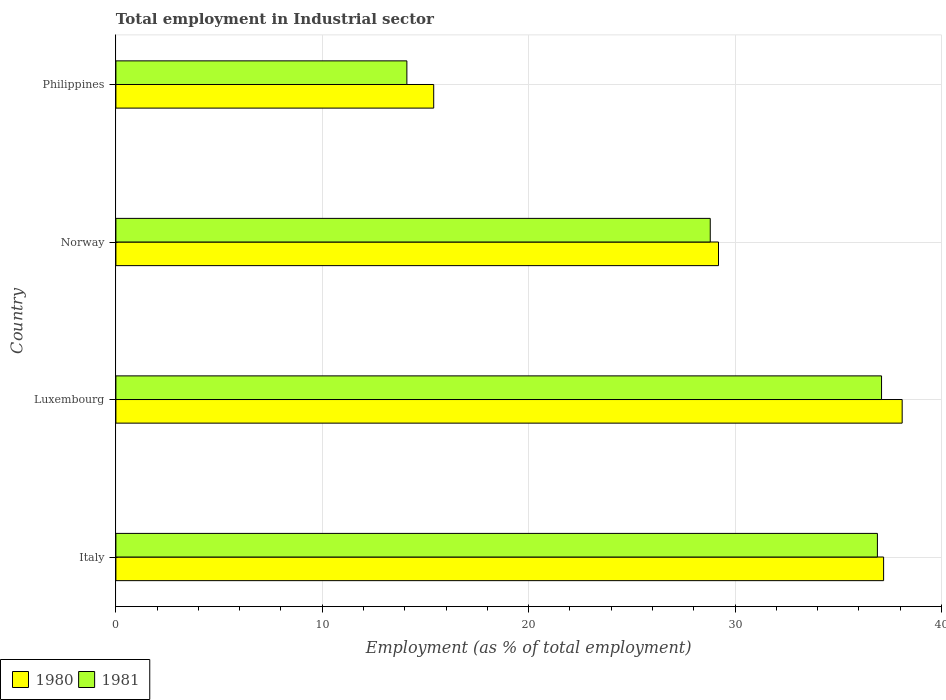How many different coloured bars are there?
Keep it short and to the point. 2. How many groups of bars are there?
Your response must be concise. 4. Are the number of bars on each tick of the Y-axis equal?
Provide a succinct answer. Yes. How many bars are there on the 1st tick from the top?
Provide a succinct answer. 2. What is the label of the 3rd group of bars from the top?
Ensure brevity in your answer.  Luxembourg. What is the employment in industrial sector in 1980 in Italy?
Keep it short and to the point. 37.2. Across all countries, what is the maximum employment in industrial sector in 1981?
Offer a terse response. 37.1. Across all countries, what is the minimum employment in industrial sector in 1981?
Keep it short and to the point. 14.1. In which country was the employment in industrial sector in 1981 maximum?
Offer a terse response. Luxembourg. What is the total employment in industrial sector in 1981 in the graph?
Your answer should be very brief. 116.9. What is the difference between the employment in industrial sector in 1980 in Luxembourg and that in Philippines?
Make the answer very short. 22.7. What is the difference between the employment in industrial sector in 1980 in Italy and the employment in industrial sector in 1981 in Norway?
Your answer should be compact. 8.4. What is the average employment in industrial sector in 1980 per country?
Give a very brief answer. 29.97. What is the difference between the employment in industrial sector in 1981 and employment in industrial sector in 1980 in Luxembourg?
Your response must be concise. -1. What is the ratio of the employment in industrial sector in 1980 in Italy to that in Philippines?
Offer a terse response. 2.42. Is the employment in industrial sector in 1980 in Luxembourg less than that in Philippines?
Offer a very short reply. No. What is the difference between the highest and the second highest employment in industrial sector in 1980?
Ensure brevity in your answer.  0.9. What is the difference between the highest and the lowest employment in industrial sector in 1980?
Ensure brevity in your answer.  22.7. What is the difference between two consecutive major ticks on the X-axis?
Provide a succinct answer. 10. Does the graph contain any zero values?
Offer a very short reply. No. Where does the legend appear in the graph?
Offer a very short reply. Bottom left. How many legend labels are there?
Provide a short and direct response. 2. What is the title of the graph?
Offer a terse response. Total employment in Industrial sector. What is the label or title of the X-axis?
Give a very brief answer. Employment (as % of total employment). What is the label or title of the Y-axis?
Ensure brevity in your answer.  Country. What is the Employment (as % of total employment) in 1980 in Italy?
Your answer should be very brief. 37.2. What is the Employment (as % of total employment) in 1981 in Italy?
Offer a terse response. 36.9. What is the Employment (as % of total employment) of 1980 in Luxembourg?
Offer a very short reply. 38.1. What is the Employment (as % of total employment) of 1981 in Luxembourg?
Give a very brief answer. 37.1. What is the Employment (as % of total employment) of 1980 in Norway?
Provide a succinct answer. 29.2. What is the Employment (as % of total employment) of 1981 in Norway?
Your response must be concise. 28.8. What is the Employment (as % of total employment) in 1980 in Philippines?
Ensure brevity in your answer.  15.4. What is the Employment (as % of total employment) of 1981 in Philippines?
Provide a succinct answer. 14.1. Across all countries, what is the maximum Employment (as % of total employment) of 1980?
Offer a very short reply. 38.1. Across all countries, what is the maximum Employment (as % of total employment) in 1981?
Your answer should be compact. 37.1. Across all countries, what is the minimum Employment (as % of total employment) in 1980?
Your answer should be very brief. 15.4. Across all countries, what is the minimum Employment (as % of total employment) in 1981?
Give a very brief answer. 14.1. What is the total Employment (as % of total employment) of 1980 in the graph?
Give a very brief answer. 119.9. What is the total Employment (as % of total employment) in 1981 in the graph?
Make the answer very short. 116.9. What is the difference between the Employment (as % of total employment) in 1980 in Italy and that in Philippines?
Ensure brevity in your answer.  21.8. What is the difference between the Employment (as % of total employment) of 1981 in Italy and that in Philippines?
Your answer should be compact. 22.8. What is the difference between the Employment (as % of total employment) in 1980 in Luxembourg and that in Norway?
Keep it short and to the point. 8.9. What is the difference between the Employment (as % of total employment) in 1980 in Luxembourg and that in Philippines?
Your answer should be compact. 22.7. What is the difference between the Employment (as % of total employment) in 1981 in Norway and that in Philippines?
Ensure brevity in your answer.  14.7. What is the difference between the Employment (as % of total employment) of 1980 in Italy and the Employment (as % of total employment) of 1981 in Philippines?
Offer a terse response. 23.1. What is the average Employment (as % of total employment) in 1980 per country?
Your response must be concise. 29.98. What is the average Employment (as % of total employment) in 1981 per country?
Your answer should be very brief. 29.23. What is the difference between the Employment (as % of total employment) of 1980 and Employment (as % of total employment) of 1981 in Italy?
Your answer should be very brief. 0.3. What is the difference between the Employment (as % of total employment) in 1980 and Employment (as % of total employment) in 1981 in Norway?
Your answer should be very brief. 0.4. What is the difference between the Employment (as % of total employment) in 1980 and Employment (as % of total employment) in 1981 in Philippines?
Your response must be concise. 1.3. What is the ratio of the Employment (as % of total employment) in 1980 in Italy to that in Luxembourg?
Keep it short and to the point. 0.98. What is the ratio of the Employment (as % of total employment) in 1980 in Italy to that in Norway?
Offer a terse response. 1.27. What is the ratio of the Employment (as % of total employment) in 1981 in Italy to that in Norway?
Offer a terse response. 1.28. What is the ratio of the Employment (as % of total employment) in 1980 in Italy to that in Philippines?
Keep it short and to the point. 2.42. What is the ratio of the Employment (as % of total employment) of 1981 in Italy to that in Philippines?
Offer a terse response. 2.62. What is the ratio of the Employment (as % of total employment) in 1980 in Luxembourg to that in Norway?
Your response must be concise. 1.3. What is the ratio of the Employment (as % of total employment) of 1981 in Luxembourg to that in Norway?
Keep it short and to the point. 1.29. What is the ratio of the Employment (as % of total employment) in 1980 in Luxembourg to that in Philippines?
Give a very brief answer. 2.47. What is the ratio of the Employment (as % of total employment) in 1981 in Luxembourg to that in Philippines?
Provide a succinct answer. 2.63. What is the ratio of the Employment (as % of total employment) in 1980 in Norway to that in Philippines?
Your response must be concise. 1.9. What is the ratio of the Employment (as % of total employment) of 1981 in Norway to that in Philippines?
Ensure brevity in your answer.  2.04. What is the difference between the highest and the lowest Employment (as % of total employment) in 1980?
Ensure brevity in your answer.  22.7. What is the difference between the highest and the lowest Employment (as % of total employment) in 1981?
Provide a succinct answer. 23. 